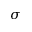<formula> <loc_0><loc_0><loc_500><loc_500>\sigma</formula> 